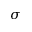<formula> <loc_0><loc_0><loc_500><loc_500>\sigma</formula> 